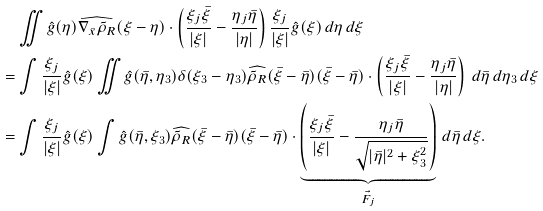Convert formula to latex. <formula><loc_0><loc_0><loc_500><loc_500>& \iint \hat { g } ( \eta ) \widehat { \nabla _ { \bar { x } } \tilde { \rho } _ { R } } ( \xi - \eta ) \cdot \left ( \frac { \xi _ { j } \bar { \xi } } { | \xi | } - \frac { \eta _ { j } \bar { \eta } } { | \eta | } \right ) \frac { \xi _ { j } } { | \xi | } \hat { g } ( \xi ) \, d \eta \, d \xi \\ = & \int \frac { \xi _ { j } } { | \xi | } \hat { g } ( \xi ) \iint \hat { g } ( \bar { \eta } , \eta _ { 3 } ) \delta ( \xi _ { 3 } - \eta _ { 3 } ) \widehat { \tilde { \rho } _ { R } } ( \bar { \xi } - \bar { \eta } ) ( \bar { \xi } - \bar { \eta } ) \cdot \left ( \frac { \xi _ { j } \bar { \xi } } { | \xi | } - \frac { \eta _ { j } \bar { \eta } } { | \eta | } \right ) \, d \bar { \eta } \, d \eta _ { 3 } \, d \xi \\ = & \int \frac { \xi _ { j } } { | \xi | } \hat { g } ( \xi ) \int \hat { g } ( \bar { \eta } , \xi _ { 3 } ) \widehat { \tilde { \rho } _ { R } } ( \bar { \xi } - \bar { \eta } ) ( \bar { \xi } - \bar { \eta } ) \cdot \underbrace { \left ( \frac { \xi _ { j } \bar { \xi } } { | \xi | } - \frac { \eta _ { j } \bar { \eta } } { \sqrt { | \bar { \eta } | ^ { 2 } + \xi _ { 3 } ^ { 2 } } } \right ) } _ { \vec { F } _ { j } } \, d \bar { \eta } \, d \xi .</formula> 